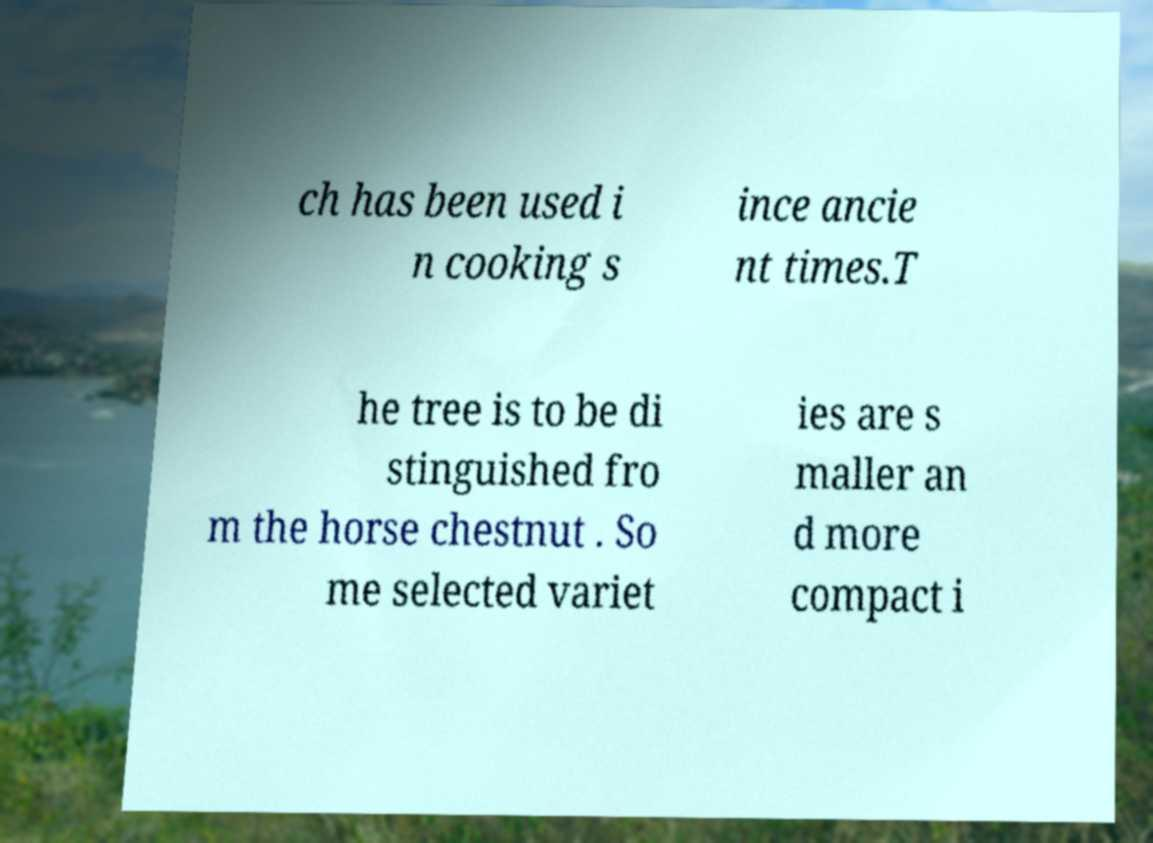Please identify and transcribe the text found in this image. ch has been used i n cooking s ince ancie nt times.T he tree is to be di stinguished fro m the horse chestnut . So me selected variet ies are s maller an d more compact i 